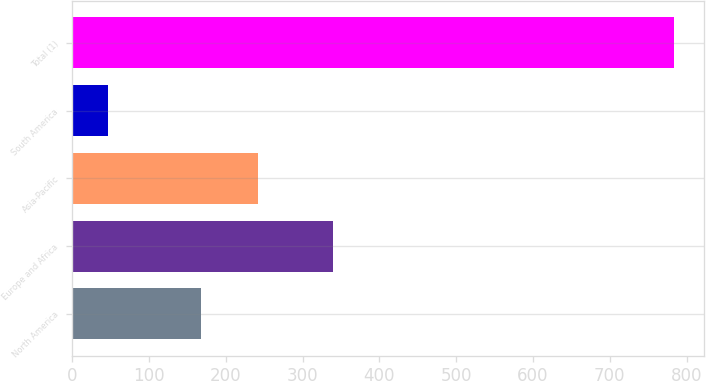Convert chart to OTSL. <chart><loc_0><loc_0><loc_500><loc_500><bar_chart><fcel>North America<fcel>Europe and Africa<fcel>Asia-Pacific<fcel>South America<fcel>Total (1)<nl><fcel>168<fcel>340<fcel>241.6<fcel>47<fcel>783<nl></chart> 